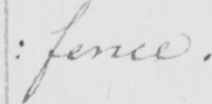Please transcribe the handwritten text in this image. : fence . 